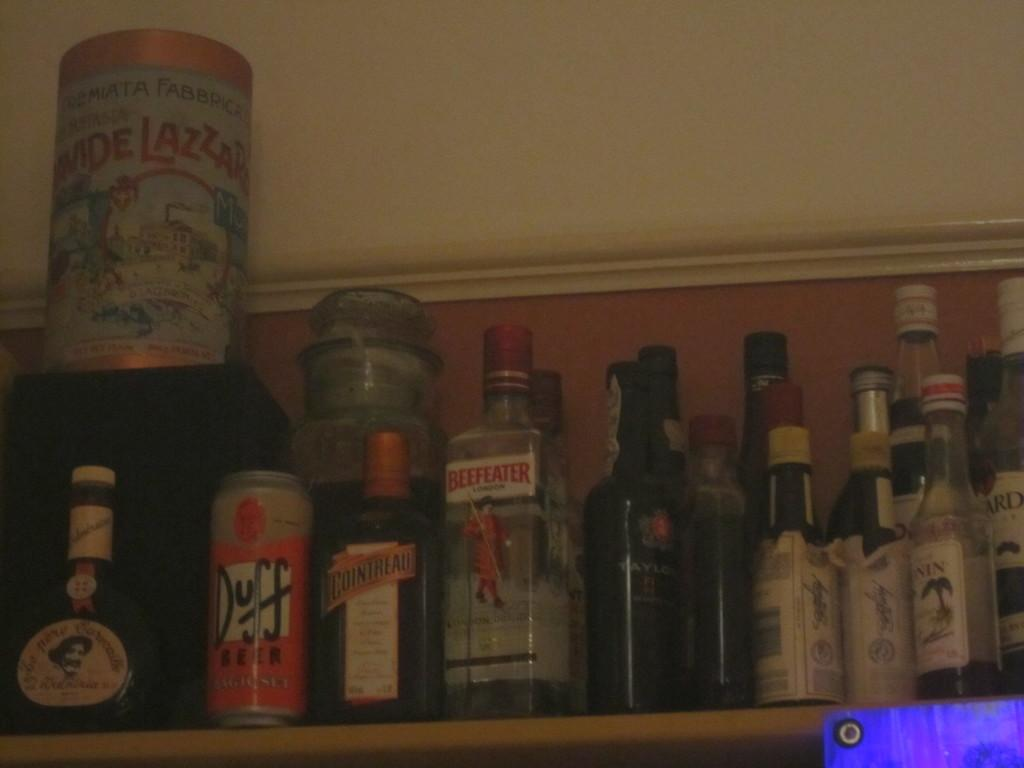What type of containers are visible in the image? There are bottles and a can in the image. How many heads can be seen on the apples in the image? There are no apples present in the image, and therefore no heads can be seen on them. 